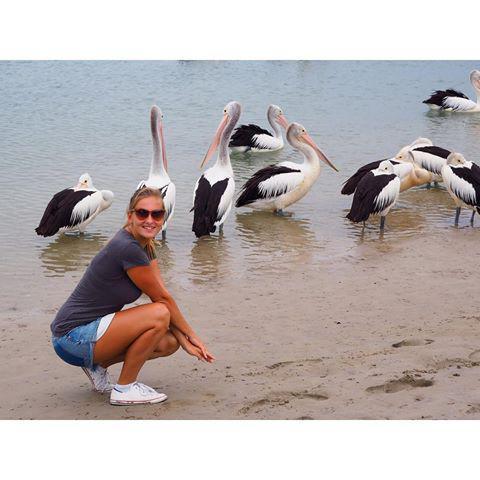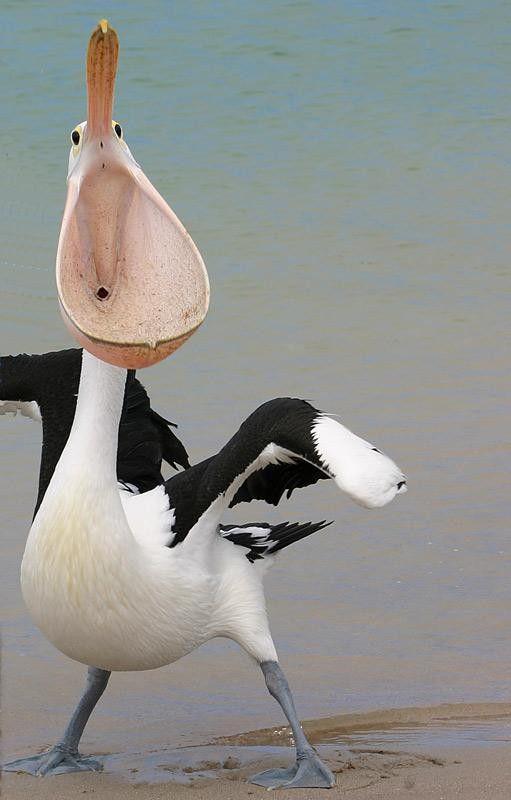The first image is the image on the left, the second image is the image on the right. Evaluate the accuracy of this statement regarding the images: "The left image contains no more than one bird.". Is it true? Answer yes or no. No. The first image is the image on the left, the second image is the image on the right. Analyze the images presented: Is the assertion "One image shows one non-standing white pelican, and the other image shows multiple black and white pelicans." valid? Answer yes or no. No. 